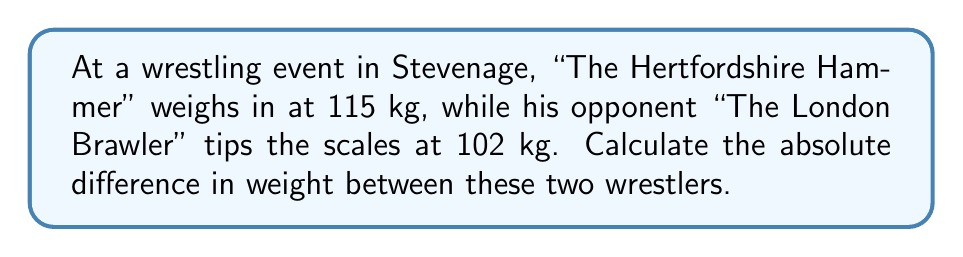Can you answer this question? To solve this problem, we need to use the concept of absolute value. The absolute value of a number represents its distance from zero on a number line, regardless of whether it's positive or negative.

Let's approach this step-by-step:

1) First, we need to find the difference between the weights:
   $115 \text{ kg} - 102 \text{ kg} = 13 \text{ kg}$

2) However, we're asked for the absolute difference. In mathematical notation, we represent the absolute value of a number $x$ as $|x|$.

3) In this case, we're calculating $|115 - 102|$

4) Since 13 is already positive, its absolute value is itself:
   $|115 - 102| = |13| = 13$

Therefore, the absolute difference in weight between "The Hertfordshire Hammer" and "The London Brawler" is 13 kg.

Note: If we had subtracted in the opposite order (102 - 115), we would have gotten -13, but the absolute value of -13 is still 13, so our answer would be the same.
Answer: $13 \text{ kg}$ 